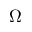<formula> <loc_0><loc_0><loc_500><loc_500>\Omega</formula> 